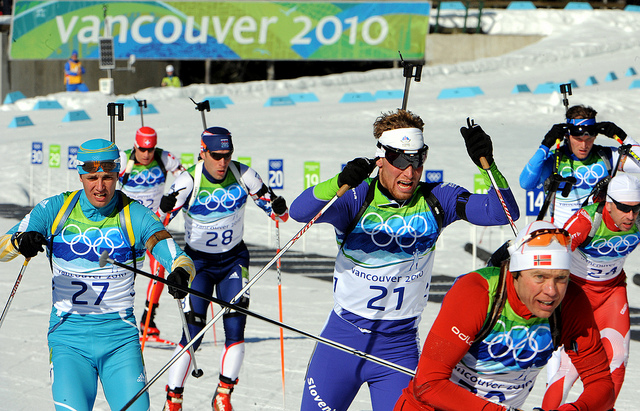How do the different pieces of equipment help the athletes in this ski race? The equipment in this ski race is integral to the athletes' performance and safety. Goggles or sunglasses protect their eyes from the harsh glare of the sun reflecting off the snow, allowing them to maintain clear vision throughout the race. These eyewear pieces are also crucial in shielding their eyes from the cold wind and any flying snow. Headbands, apart from showcasing team colors, are vital for absorbing sweat, preventing it from interfering with their vision. Ski poles are essential for propulsion and balance, allowing the athletes to navigate the course efficiently and maintain their speed. Ski boots provide a secure connection between the skier and their skis, ensuring control and responsiveness. The attire, often made from insulated and breathable materials, keeps the skiers warm yet unrestricted. Each piece of this carefully designed equipment works together to optimize the athlete's performance on the challenging course. 